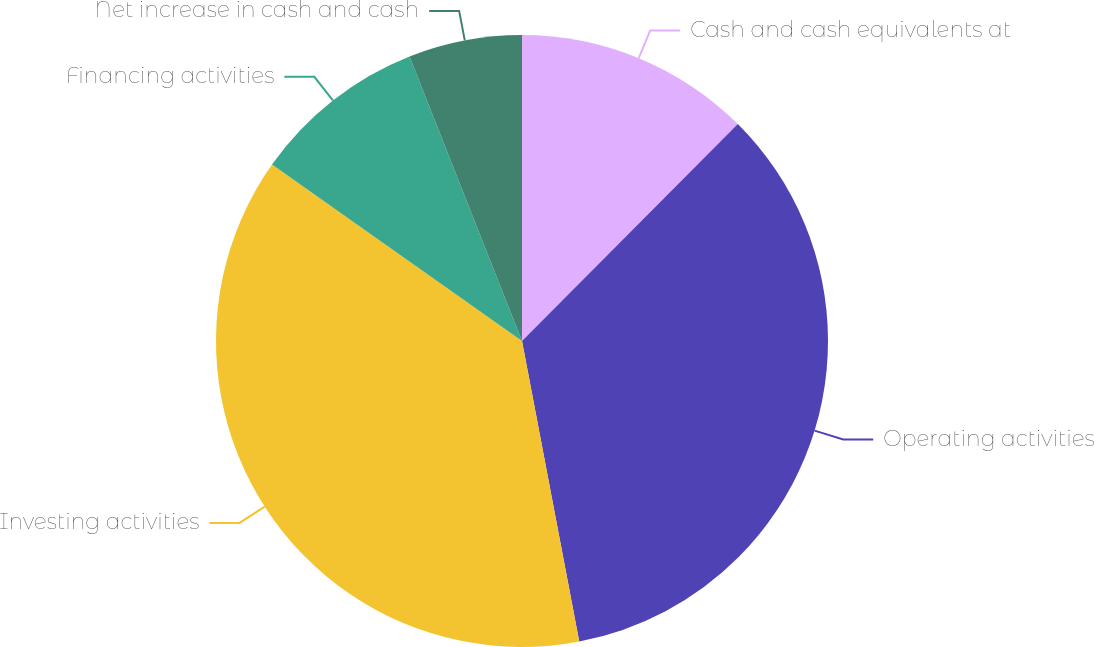Convert chart to OTSL. <chart><loc_0><loc_0><loc_500><loc_500><pie_chart><fcel>Cash and cash equivalents at<fcel>Operating activities<fcel>Investing activities<fcel>Financing activities<fcel>Net increase in cash and cash<nl><fcel>12.46%<fcel>34.55%<fcel>37.78%<fcel>9.23%<fcel>5.99%<nl></chart> 